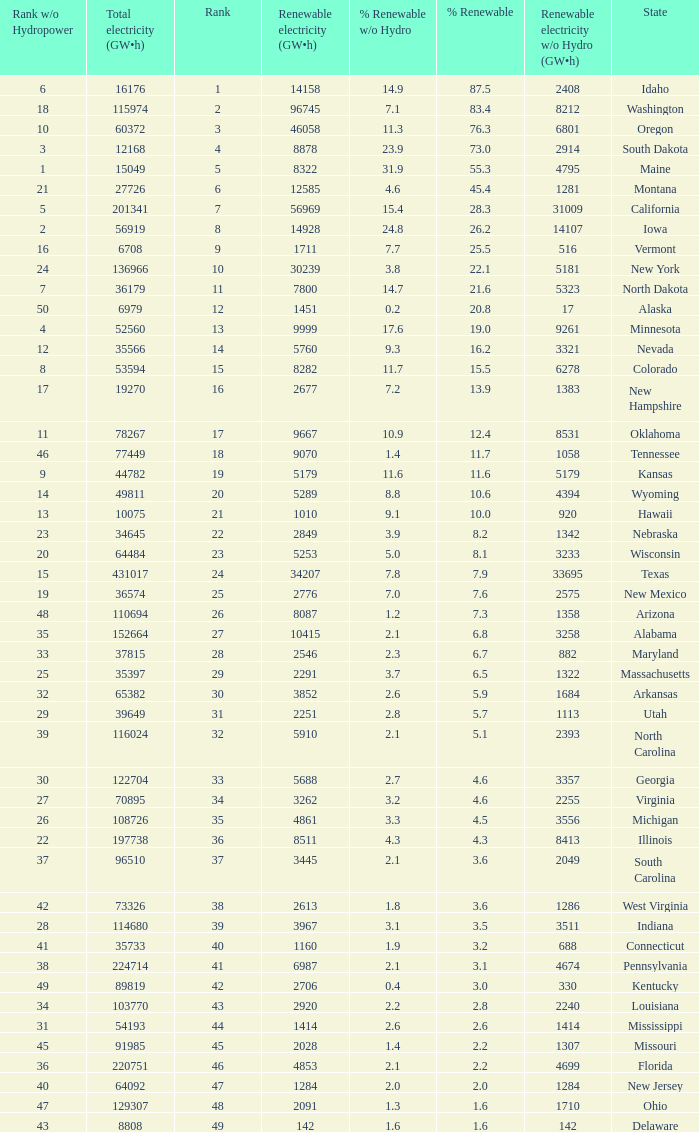What is the amount of renewable electricity without hydrogen power when the percentage of renewable energy is 83.4? 8212.0. 